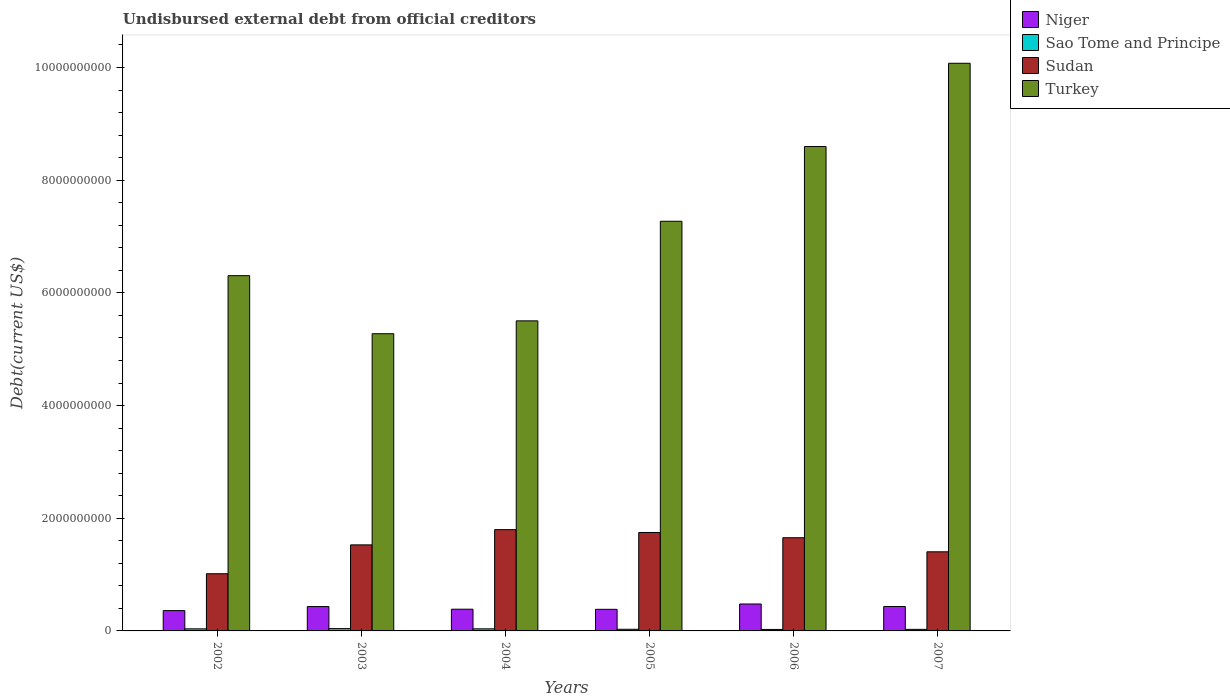How many different coloured bars are there?
Provide a short and direct response. 4. Are the number of bars per tick equal to the number of legend labels?
Give a very brief answer. Yes. Are the number of bars on each tick of the X-axis equal?
Make the answer very short. Yes. How many bars are there on the 3rd tick from the left?
Provide a short and direct response. 4. How many bars are there on the 3rd tick from the right?
Offer a terse response. 4. What is the label of the 1st group of bars from the left?
Make the answer very short. 2002. What is the total debt in Sao Tome and Principe in 2002?
Provide a succinct answer. 3.68e+07. Across all years, what is the maximum total debt in Sudan?
Your answer should be compact. 1.80e+09. Across all years, what is the minimum total debt in Sudan?
Your answer should be very brief. 1.02e+09. In which year was the total debt in Turkey minimum?
Your answer should be very brief. 2003. What is the total total debt in Turkey in the graph?
Provide a succinct answer. 4.30e+1. What is the difference between the total debt in Sao Tome and Principe in 2002 and that in 2005?
Make the answer very short. 7.40e+06. What is the difference between the total debt in Turkey in 2005 and the total debt in Sao Tome and Principe in 2006?
Your answer should be very brief. 7.24e+09. What is the average total debt in Sudan per year?
Provide a short and direct response. 1.52e+09. In the year 2007, what is the difference between the total debt in Turkey and total debt in Sao Tome and Principe?
Your response must be concise. 1.00e+1. In how many years, is the total debt in Niger greater than 2400000000 US$?
Offer a terse response. 0. What is the ratio of the total debt in Niger in 2003 to that in 2005?
Offer a terse response. 1.13. Is the total debt in Sudan in 2003 less than that in 2004?
Ensure brevity in your answer.  Yes. Is the difference between the total debt in Turkey in 2002 and 2004 greater than the difference between the total debt in Sao Tome and Principe in 2002 and 2004?
Your answer should be very brief. Yes. What is the difference between the highest and the second highest total debt in Turkey?
Make the answer very short. 1.48e+09. What is the difference between the highest and the lowest total debt in Turkey?
Offer a terse response. 4.80e+09. Is the sum of the total debt in Niger in 2003 and 2005 greater than the maximum total debt in Sao Tome and Principe across all years?
Provide a short and direct response. Yes. What does the 3rd bar from the left in 2004 represents?
Your answer should be very brief. Sudan. What does the 3rd bar from the right in 2005 represents?
Your answer should be compact. Sao Tome and Principe. Are all the bars in the graph horizontal?
Offer a terse response. No. Does the graph contain grids?
Offer a terse response. No. Where does the legend appear in the graph?
Ensure brevity in your answer.  Top right. How many legend labels are there?
Make the answer very short. 4. What is the title of the graph?
Your response must be concise. Undisbursed external debt from official creditors. Does "Lower middle income" appear as one of the legend labels in the graph?
Offer a terse response. No. What is the label or title of the Y-axis?
Your answer should be compact. Debt(current US$). What is the Debt(current US$) of Niger in 2002?
Provide a short and direct response. 3.61e+08. What is the Debt(current US$) in Sao Tome and Principe in 2002?
Ensure brevity in your answer.  3.68e+07. What is the Debt(current US$) of Sudan in 2002?
Provide a succinct answer. 1.02e+09. What is the Debt(current US$) in Turkey in 2002?
Your response must be concise. 6.31e+09. What is the Debt(current US$) in Niger in 2003?
Your answer should be compact. 4.32e+08. What is the Debt(current US$) in Sao Tome and Principe in 2003?
Offer a very short reply. 4.12e+07. What is the Debt(current US$) in Sudan in 2003?
Give a very brief answer. 1.53e+09. What is the Debt(current US$) in Turkey in 2003?
Your response must be concise. 5.28e+09. What is the Debt(current US$) in Niger in 2004?
Keep it short and to the point. 3.85e+08. What is the Debt(current US$) in Sao Tome and Principe in 2004?
Your response must be concise. 3.71e+07. What is the Debt(current US$) in Sudan in 2004?
Provide a short and direct response. 1.80e+09. What is the Debt(current US$) of Turkey in 2004?
Provide a succinct answer. 5.50e+09. What is the Debt(current US$) in Niger in 2005?
Give a very brief answer. 3.83e+08. What is the Debt(current US$) of Sao Tome and Principe in 2005?
Give a very brief answer. 2.94e+07. What is the Debt(current US$) in Sudan in 2005?
Offer a very short reply. 1.75e+09. What is the Debt(current US$) in Turkey in 2005?
Your answer should be compact. 7.27e+09. What is the Debt(current US$) in Niger in 2006?
Keep it short and to the point. 4.78e+08. What is the Debt(current US$) in Sao Tome and Principe in 2006?
Your answer should be very brief. 2.65e+07. What is the Debt(current US$) of Sudan in 2006?
Your response must be concise. 1.65e+09. What is the Debt(current US$) of Turkey in 2006?
Give a very brief answer. 8.60e+09. What is the Debt(current US$) of Niger in 2007?
Your answer should be very brief. 4.34e+08. What is the Debt(current US$) of Sao Tome and Principe in 2007?
Provide a short and direct response. 2.78e+07. What is the Debt(current US$) of Sudan in 2007?
Give a very brief answer. 1.40e+09. What is the Debt(current US$) in Turkey in 2007?
Ensure brevity in your answer.  1.01e+1. Across all years, what is the maximum Debt(current US$) of Niger?
Offer a terse response. 4.78e+08. Across all years, what is the maximum Debt(current US$) in Sao Tome and Principe?
Your answer should be very brief. 4.12e+07. Across all years, what is the maximum Debt(current US$) in Sudan?
Give a very brief answer. 1.80e+09. Across all years, what is the maximum Debt(current US$) of Turkey?
Make the answer very short. 1.01e+1. Across all years, what is the minimum Debt(current US$) of Niger?
Offer a very short reply. 3.61e+08. Across all years, what is the minimum Debt(current US$) of Sao Tome and Principe?
Make the answer very short. 2.65e+07. Across all years, what is the minimum Debt(current US$) in Sudan?
Offer a very short reply. 1.02e+09. Across all years, what is the minimum Debt(current US$) in Turkey?
Ensure brevity in your answer.  5.28e+09. What is the total Debt(current US$) in Niger in the graph?
Give a very brief answer. 2.47e+09. What is the total Debt(current US$) in Sao Tome and Principe in the graph?
Your answer should be very brief. 1.99e+08. What is the total Debt(current US$) of Sudan in the graph?
Your response must be concise. 9.15e+09. What is the total Debt(current US$) of Turkey in the graph?
Ensure brevity in your answer.  4.30e+1. What is the difference between the Debt(current US$) of Niger in 2002 and that in 2003?
Your response must be concise. -7.17e+07. What is the difference between the Debt(current US$) of Sao Tome and Principe in 2002 and that in 2003?
Ensure brevity in your answer.  -4.41e+06. What is the difference between the Debt(current US$) in Sudan in 2002 and that in 2003?
Ensure brevity in your answer.  -5.12e+08. What is the difference between the Debt(current US$) of Turkey in 2002 and that in 2003?
Your answer should be very brief. 1.03e+09. What is the difference between the Debt(current US$) in Niger in 2002 and that in 2004?
Make the answer very short. -2.46e+07. What is the difference between the Debt(current US$) in Sao Tome and Principe in 2002 and that in 2004?
Provide a short and direct response. -3.19e+05. What is the difference between the Debt(current US$) of Sudan in 2002 and that in 2004?
Make the answer very short. -7.83e+08. What is the difference between the Debt(current US$) in Turkey in 2002 and that in 2004?
Offer a terse response. 8.02e+08. What is the difference between the Debt(current US$) of Niger in 2002 and that in 2005?
Your answer should be compact. -2.27e+07. What is the difference between the Debt(current US$) of Sao Tome and Principe in 2002 and that in 2005?
Your answer should be very brief. 7.40e+06. What is the difference between the Debt(current US$) of Sudan in 2002 and that in 2005?
Offer a terse response. -7.32e+08. What is the difference between the Debt(current US$) of Turkey in 2002 and that in 2005?
Make the answer very short. -9.65e+08. What is the difference between the Debt(current US$) in Niger in 2002 and that in 2006?
Your answer should be compact. -1.17e+08. What is the difference between the Debt(current US$) in Sao Tome and Principe in 2002 and that in 2006?
Offer a very short reply. 1.02e+07. What is the difference between the Debt(current US$) in Sudan in 2002 and that in 2006?
Provide a succinct answer. -6.39e+08. What is the difference between the Debt(current US$) in Turkey in 2002 and that in 2006?
Make the answer very short. -2.29e+09. What is the difference between the Debt(current US$) of Niger in 2002 and that in 2007?
Provide a short and direct response. -7.28e+07. What is the difference between the Debt(current US$) of Sao Tome and Principe in 2002 and that in 2007?
Offer a terse response. 8.94e+06. What is the difference between the Debt(current US$) in Sudan in 2002 and that in 2007?
Offer a terse response. -3.89e+08. What is the difference between the Debt(current US$) in Turkey in 2002 and that in 2007?
Provide a short and direct response. -3.77e+09. What is the difference between the Debt(current US$) of Niger in 2003 and that in 2004?
Your answer should be very brief. 4.70e+07. What is the difference between the Debt(current US$) of Sao Tome and Principe in 2003 and that in 2004?
Ensure brevity in your answer.  4.09e+06. What is the difference between the Debt(current US$) in Sudan in 2003 and that in 2004?
Your response must be concise. -2.71e+08. What is the difference between the Debt(current US$) in Turkey in 2003 and that in 2004?
Make the answer very short. -2.28e+08. What is the difference between the Debt(current US$) of Niger in 2003 and that in 2005?
Offer a very short reply. 4.89e+07. What is the difference between the Debt(current US$) of Sao Tome and Principe in 2003 and that in 2005?
Offer a very short reply. 1.18e+07. What is the difference between the Debt(current US$) in Sudan in 2003 and that in 2005?
Offer a very short reply. -2.20e+08. What is the difference between the Debt(current US$) of Turkey in 2003 and that in 2005?
Make the answer very short. -2.00e+09. What is the difference between the Debt(current US$) of Niger in 2003 and that in 2006?
Give a very brief answer. -4.54e+07. What is the difference between the Debt(current US$) of Sao Tome and Principe in 2003 and that in 2006?
Your response must be concise. 1.46e+07. What is the difference between the Debt(current US$) in Sudan in 2003 and that in 2006?
Offer a terse response. -1.27e+08. What is the difference between the Debt(current US$) of Turkey in 2003 and that in 2006?
Your answer should be very brief. -3.32e+09. What is the difference between the Debt(current US$) in Niger in 2003 and that in 2007?
Give a very brief answer. -1.14e+06. What is the difference between the Debt(current US$) of Sao Tome and Principe in 2003 and that in 2007?
Your answer should be very brief. 1.34e+07. What is the difference between the Debt(current US$) of Sudan in 2003 and that in 2007?
Provide a short and direct response. 1.23e+08. What is the difference between the Debt(current US$) of Turkey in 2003 and that in 2007?
Keep it short and to the point. -4.80e+09. What is the difference between the Debt(current US$) in Niger in 2004 and that in 2005?
Your answer should be compact. 1.90e+06. What is the difference between the Debt(current US$) in Sao Tome and Principe in 2004 and that in 2005?
Your answer should be compact. 7.72e+06. What is the difference between the Debt(current US$) of Sudan in 2004 and that in 2005?
Provide a short and direct response. 5.05e+07. What is the difference between the Debt(current US$) of Turkey in 2004 and that in 2005?
Your response must be concise. -1.77e+09. What is the difference between the Debt(current US$) of Niger in 2004 and that in 2006?
Your answer should be very brief. -9.25e+07. What is the difference between the Debt(current US$) in Sao Tome and Principe in 2004 and that in 2006?
Provide a succinct answer. 1.06e+07. What is the difference between the Debt(current US$) in Sudan in 2004 and that in 2006?
Your answer should be compact. 1.44e+08. What is the difference between the Debt(current US$) of Turkey in 2004 and that in 2006?
Give a very brief answer. -3.09e+09. What is the difference between the Debt(current US$) of Niger in 2004 and that in 2007?
Provide a short and direct response. -4.82e+07. What is the difference between the Debt(current US$) in Sao Tome and Principe in 2004 and that in 2007?
Keep it short and to the point. 9.26e+06. What is the difference between the Debt(current US$) of Sudan in 2004 and that in 2007?
Provide a short and direct response. 3.93e+08. What is the difference between the Debt(current US$) of Turkey in 2004 and that in 2007?
Your response must be concise. -4.57e+09. What is the difference between the Debt(current US$) of Niger in 2005 and that in 2006?
Offer a terse response. -9.44e+07. What is the difference between the Debt(current US$) of Sao Tome and Principe in 2005 and that in 2006?
Offer a terse response. 2.83e+06. What is the difference between the Debt(current US$) in Sudan in 2005 and that in 2006?
Your answer should be compact. 9.31e+07. What is the difference between the Debt(current US$) in Turkey in 2005 and that in 2006?
Offer a very short reply. -1.33e+09. What is the difference between the Debt(current US$) in Niger in 2005 and that in 2007?
Give a very brief answer. -5.01e+07. What is the difference between the Debt(current US$) of Sao Tome and Principe in 2005 and that in 2007?
Provide a short and direct response. 1.54e+06. What is the difference between the Debt(current US$) in Sudan in 2005 and that in 2007?
Make the answer very short. 3.43e+08. What is the difference between the Debt(current US$) in Turkey in 2005 and that in 2007?
Your response must be concise. -2.80e+09. What is the difference between the Debt(current US$) in Niger in 2006 and that in 2007?
Offer a very short reply. 4.43e+07. What is the difference between the Debt(current US$) in Sao Tome and Principe in 2006 and that in 2007?
Keep it short and to the point. -1.29e+06. What is the difference between the Debt(current US$) of Sudan in 2006 and that in 2007?
Give a very brief answer. 2.50e+08. What is the difference between the Debt(current US$) of Turkey in 2006 and that in 2007?
Ensure brevity in your answer.  -1.48e+09. What is the difference between the Debt(current US$) in Niger in 2002 and the Debt(current US$) in Sao Tome and Principe in 2003?
Provide a succinct answer. 3.20e+08. What is the difference between the Debt(current US$) of Niger in 2002 and the Debt(current US$) of Sudan in 2003?
Offer a terse response. -1.17e+09. What is the difference between the Debt(current US$) in Niger in 2002 and the Debt(current US$) in Turkey in 2003?
Your answer should be compact. -4.91e+09. What is the difference between the Debt(current US$) of Sao Tome and Principe in 2002 and the Debt(current US$) of Sudan in 2003?
Keep it short and to the point. -1.49e+09. What is the difference between the Debt(current US$) in Sao Tome and Principe in 2002 and the Debt(current US$) in Turkey in 2003?
Offer a very short reply. -5.24e+09. What is the difference between the Debt(current US$) in Sudan in 2002 and the Debt(current US$) in Turkey in 2003?
Give a very brief answer. -4.26e+09. What is the difference between the Debt(current US$) of Niger in 2002 and the Debt(current US$) of Sao Tome and Principe in 2004?
Make the answer very short. 3.24e+08. What is the difference between the Debt(current US$) of Niger in 2002 and the Debt(current US$) of Sudan in 2004?
Keep it short and to the point. -1.44e+09. What is the difference between the Debt(current US$) of Niger in 2002 and the Debt(current US$) of Turkey in 2004?
Your response must be concise. -5.14e+09. What is the difference between the Debt(current US$) in Sao Tome and Principe in 2002 and the Debt(current US$) in Sudan in 2004?
Offer a terse response. -1.76e+09. What is the difference between the Debt(current US$) in Sao Tome and Principe in 2002 and the Debt(current US$) in Turkey in 2004?
Provide a succinct answer. -5.47e+09. What is the difference between the Debt(current US$) in Sudan in 2002 and the Debt(current US$) in Turkey in 2004?
Offer a very short reply. -4.49e+09. What is the difference between the Debt(current US$) in Niger in 2002 and the Debt(current US$) in Sao Tome and Principe in 2005?
Your answer should be very brief. 3.31e+08. What is the difference between the Debt(current US$) in Niger in 2002 and the Debt(current US$) in Sudan in 2005?
Your response must be concise. -1.39e+09. What is the difference between the Debt(current US$) of Niger in 2002 and the Debt(current US$) of Turkey in 2005?
Your answer should be compact. -6.91e+09. What is the difference between the Debt(current US$) of Sao Tome and Principe in 2002 and the Debt(current US$) of Sudan in 2005?
Provide a succinct answer. -1.71e+09. What is the difference between the Debt(current US$) in Sao Tome and Principe in 2002 and the Debt(current US$) in Turkey in 2005?
Your response must be concise. -7.23e+09. What is the difference between the Debt(current US$) in Sudan in 2002 and the Debt(current US$) in Turkey in 2005?
Make the answer very short. -6.26e+09. What is the difference between the Debt(current US$) in Niger in 2002 and the Debt(current US$) in Sao Tome and Principe in 2006?
Provide a short and direct response. 3.34e+08. What is the difference between the Debt(current US$) in Niger in 2002 and the Debt(current US$) in Sudan in 2006?
Your answer should be very brief. -1.29e+09. What is the difference between the Debt(current US$) in Niger in 2002 and the Debt(current US$) in Turkey in 2006?
Your response must be concise. -8.24e+09. What is the difference between the Debt(current US$) of Sao Tome and Principe in 2002 and the Debt(current US$) of Sudan in 2006?
Keep it short and to the point. -1.62e+09. What is the difference between the Debt(current US$) of Sao Tome and Principe in 2002 and the Debt(current US$) of Turkey in 2006?
Provide a succinct answer. -8.56e+09. What is the difference between the Debt(current US$) of Sudan in 2002 and the Debt(current US$) of Turkey in 2006?
Ensure brevity in your answer.  -7.58e+09. What is the difference between the Debt(current US$) of Niger in 2002 and the Debt(current US$) of Sao Tome and Principe in 2007?
Provide a succinct answer. 3.33e+08. What is the difference between the Debt(current US$) of Niger in 2002 and the Debt(current US$) of Sudan in 2007?
Offer a very short reply. -1.04e+09. What is the difference between the Debt(current US$) of Niger in 2002 and the Debt(current US$) of Turkey in 2007?
Your answer should be compact. -9.71e+09. What is the difference between the Debt(current US$) in Sao Tome and Principe in 2002 and the Debt(current US$) in Sudan in 2007?
Keep it short and to the point. -1.37e+09. What is the difference between the Debt(current US$) of Sao Tome and Principe in 2002 and the Debt(current US$) of Turkey in 2007?
Give a very brief answer. -1.00e+1. What is the difference between the Debt(current US$) of Sudan in 2002 and the Debt(current US$) of Turkey in 2007?
Offer a terse response. -9.06e+09. What is the difference between the Debt(current US$) in Niger in 2003 and the Debt(current US$) in Sao Tome and Principe in 2004?
Your answer should be compact. 3.95e+08. What is the difference between the Debt(current US$) of Niger in 2003 and the Debt(current US$) of Sudan in 2004?
Offer a very short reply. -1.37e+09. What is the difference between the Debt(current US$) of Niger in 2003 and the Debt(current US$) of Turkey in 2004?
Offer a very short reply. -5.07e+09. What is the difference between the Debt(current US$) in Sao Tome and Principe in 2003 and the Debt(current US$) in Sudan in 2004?
Provide a short and direct response. -1.76e+09. What is the difference between the Debt(current US$) of Sao Tome and Principe in 2003 and the Debt(current US$) of Turkey in 2004?
Make the answer very short. -5.46e+09. What is the difference between the Debt(current US$) of Sudan in 2003 and the Debt(current US$) of Turkey in 2004?
Your response must be concise. -3.98e+09. What is the difference between the Debt(current US$) of Niger in 2003 and the Debt(current US$) of Sao Tome and Principe in 2005?
Offer a terse response. 4.03e+08. What is the difference between the Debt(current US$) in Niger in 2003 and the Debt(current US$) in Sudan in 2005?
Your response must be concise. -1.31e+09. What is the difference between the Debt(current US$) of Niger in 2003 and the Debt(current US$) of Turkey in 2005?
Keep it short and to the point. -6.84e+09. What is the difference between the Debt(current US$) of Sao Tome and Principe in 2003 and the Debt(current US$) of Sudan in 2005?
Ensure brevity in your answer.  -1.71e+09. What is the difference between the Debt(current US$) in Sao Tome and Principe in 2003 and the Debt(current US$) in Turkey in 2005?
Offer a terse response. -7.23e+09. What is the difference between the Debt(current US$) in Sudan in 2003 and the Debt(current US$) in Turkey in 2005?
Your answer should be very brief. -5.74e+09. What is the difference between the Debt(current US$) of Niger in 2003 and the Debt(current US$) of Sao Tome and Principe in 2006?
Make the answer very short. 4.06e+08. What is the difference between the Debt(current US$) in Niger in 2003 and the Debt(current US$) in Sudan in 2006?
Give a very brief answer. -1.22e+09. What is the difference between the Debt(current US$) in Niger in 2003 and the Debt(current US$) in Turkey in 2006?
Provide a short and direct response. -8.16e+09. What is the difference between the Debt(current US$) of Sao Tome and Principe in 2003 and the Debt(current US$) of Sudan in 2006?
Offer a terse response. -1.61e+09. What is the difference between the Debt(current US$) in Sao Tome and Principe in 2003 and the Debt(current US$) in Turkey in 2006?
Offer a terse response. -8.56e+09. What is the difference between the Debt(current US$) in Sudan in 2003 and the Debt(current US$) in Turkey in 2006?
Your answer should be compact. -7.07e+09. What is the difference between the Debt(current US$) in Niger in 2003 and the Debt(current US$) in Sao Tome and Principe in 2007?
Offer a very short reply. 4.05e+08. What is the difference between the Debt(current US$) of Niger in 2003 and the Debt(current US$) of Sudan in 2007?
Offer a very short reply. -9.72e+08. What is the difference between the Debt(current US$) of Niger in 2003 and the Debt(current US$) of Turkey in 2007?
Make the answer very short. -9.64e+09. What is the difference between the Debt(current US$) of Sao Tome and Principe in 2003 and the Debt(current US$) of Sudan in 2007?
Provide a succinct answer. -1.36e+09. What is the difference between the Debt(current US$) of Sao Tome and Principe in 2003 and the Debt(current US$) of Turkey in 2007?
Provide a succinct answer. -1.00e+1. What is the difference between the Debt(current US$) in Sudan in 2003 and the Debt(current US$) in Turkey in 2007?
Offer a terse response. -8.55e+09. What is the difference between the Debt(current US$) of Niger in 2004 and the Debt(current US$) of Sao Tome and Principe in 2005?
Make the answer very short. 3.56e+08. What is the difference between the Debt(current US$) of Niger in 2004 and the Debt(current US$) of Sudan in 2005?
Offer a terse response. -1.36e+09. What is the difference between the Debt(current US$) in Niger in 2004 and the Debt(current US$) in Turkey in 2005?
Make the answer very short. -6.89e+09. What is the difference between the Debt(current US$) in Sao Tome and Principe in 2004 and the Debt(current US$) in Sudan in 2005?
Your answer should be compact. -1.71e+09. What is the difference between the Debt(current US$) in Sao Tome and Principe in 2004 and the Debt(current US$) in Turkey in 2005?
Your answer should be very brief. -7.23e+09. What is the difference between the Debt(current US$) in Sudan in 2004 and the Debt(current US$) in Turkey in 2005?
Provide a short and direct response. -5.47e+09. What is the difference between the Debt(current US$) of Niger in 2004 and the Debt(current US$) of Sao Tome and Principe in 2006?
Provide a short and direct response. 3.59e+08. What is the difference between the Debt(current US$) in Niger in 2004 and the Debt(current US$) in Sudan in 2006?
Provide a short and direct response. -1.27e+09. What is the difference between the Debt(current US$) of Niger in 2004 and the Debt(current US$) of Turkey in 2006?
Your response must be concise. -8.21e+09. What is the difference between the Debt(current US$) in Sao Tome and Principe in 2004 and the Debt(current US$) in Sudan in 2006?
Provide a short and direct response. -1.62e+09. What is the difference between the Debt(current US$) in Sao Tome and Principe in 2004 and the Debt(current US$) in Turkey in 2006?
Give a very brief answer. -8.56e+09. What is the difference between the Debt(current US$) in Sudan in 2004 and the Debt(current US$) in Turkey in 2006?
Your answer should be very brief. -6.80e+09. What is the difference between the Debt(current US$) of Niger in 2004 and the Debt(current US$) of Sao Tome and Principe in 2007?
Your response must be concise. 3.58e+08. What is the difference between the Debt(current US$) of Niger in 2004 and the Debt(current US$) of Sudan in 2007?
Your answer should be compact. -1.02e+09. What is the difference between the Debt(current US$) in Niger in 2004 and the Debt(current US$) in Turkey in 2007?
Provide a short and direct response. -9.69e+09. What is the difference between the Debt(current US$) in Sao Tome and Principe in 2004 and the Debt(current US$) in Sudan in 2007?
Offer a very short reply. -1.37e+09. What is the difference between the Debt(current US$) of Sao Tome and Principe in 2004 and the Debt(current US$) of Turkey in 2007?
Ensure brevity in your answer.  -1.00e+1. What is the difference between the Debt(current US$) of Sudan in 2004 and the Debt(current US$) of Turkey in 2007?
Your answer should be compact. -8.28e+09. What is the difference between the Debt(current US$) in Niger in 2005 and the Debt(current US$) in Sao Tome and Principe in 2006?
Your response must be concise. 3.57e+08. What is the difference between the Debt(current US$) in Niger in 2005 and the Debt(current US$) in Sudan in 2006?
Keep it short and to the point. -1.27e+09. What is the difference between the Debt(current US$) of Niger in 2005 and the Debt(current US$) of Turkey in 2006?
Your answer should be compact. -8.21e+09. What is the difference between the Debt(current US$) of Sao Tome and Principe in 2005 and the Debt(current US$) of Sudan in 2006?
Give a very brief answer. -1.62e+09. What is the difference between the Debt(current US$) in Sao Tome and Principe in 2005 and the Debt(current US$) in Turkey in 2006?
Make the answer very short. -8.57e+09. What is the difference between the Debt(current US$) of Sudan in 2005 and the Debt(current US$) of Turkey in 2006?
Make the answer very short. -6.85e+09. What is the difference between the Debt(current US$) of Niger in 2005 and the Debt(current US$) of Sao Tome and Principe in 2007?
Your response must be concise. 3.56e+08. What is the difference between the Debt(current US$) in Niger in 2005 and the Debt(current US$) in Sudan in 2007?
Your answer should be compact. -1.02e+09. What is the difference between the Debt(current US$) of Niger in 2005 and the Debt(current US$) of Turkey in 2007?
Provide a short and direct response. -9.69e+09. What is the difference between the Debt(current US$) of Sao Tome and Principe in 2005 and the Debt(current US$) of Sudan in 2007?
Your answer should be very brief. -1.37e+09. What is the difference between the Debt(current US$) of Sao Tome and Principe in 2005 and the Debt(current US$) of Turkey in 2007?
Provide a short and direct response. -1.00e+1. What is the difference between the Debt(current US$) of Sudan in 2005 and the Debt(current US$) of Turkey in 2007?
Offer a very short reply. -8.33e+09. What is the difference between the Debt(current US$) of Niger in 2006 and the Debt(current US$) of Sao Tome and Principe in 2007?
Keep it short and to the point. 4.50e+08. What is the difference between the Debt(current US$) of Niger in 2006 and the Debt(current US$) of Sudan in 2007?
Your answer should be very brief. -9.26e+08. What is the difference between the Debt(current US$) in Niger in 2006 and the Debt(current US$) in Turkey in 2007?
Provide a short and direct response. -9.60e+09. What is the difference between the Debt(current US$) in Sao Tome and Principe in 2006 and the Debt(current US$) in Sudan in 2007?
Your answer should be compact. -1.38e+09. What is the difference between the Debt(current US$) in Sao Tome and Principe in 2006 and the Debt(current US$) in Turkey in 2007?
Keep it short and to the point. -1.00e+1. What is the difference between the Debt(current US$) of Sudan in 2006 and the Debt(current US$) of Turkey in 2007?
Offer a terse response. -8.42e+09. What is the average Debt(current US$) of Niger per year?
Offer a terse response. 4.12e+08. What is the average Debt(current US$) in Sao Tome and Principe per year?
Give a very brief answer. 3.31e+07. What is the average Debt(current US$) in Sudan per year?
Keep it short and to the point. 1.52e+09. What is the average Debt(current US$) in Turkey per year?
Make the answer very short. 7.17e+09. In the year 2002, what is the difference between the Debt(current US$) in Niger and Debt(current US$) in Sao Tome and Principe?
Ensure brevity in your answer.  3.24e+08. In the year 2002, what is the difference between the Debt(current US$) of Niger and Debt(current US$) of Sudan?
Your answer should be compact. -6.54e+08. In the year 2002, what is the difference between the Debt(current US$) in Niger and Debt(current US$) in Turkey?
Your answer should be very brief. -5.94e+09. In the year 2002, what is the difference between the Debt(current US$) in Sao Tome and Principe and Debt(current US$) in Sudan?
Offer a terse response. -9.78e+08. In the year 2002, what is the difference between the Debt(current US$) of Sao Tome and Principe and Debt(current US$) of Turkey?
Make the answer very short. -6.27e+09. In the year 2002, what is the difference between the Debt(current US$) in Sudan and Debt(current US$) in Turkey?
Your response must be concise. -5.29e+09. In the year 2003, what is the difference between the Debt(current US$) of Niger and Debt(current US$) of Sao Tome and Principe?
Offer a terse response. 3.91e+08. In the year 2003, what is the difference between the Debt(current US$) in Niger and Debt(current US$) in Sudan?
Make the answer very short. -1.09e+09. In the year 2003, what is the difference between the Debt(current US$) in Niger and Debt(current US$) in Turkey?
Offer a very short reply. -4.84e+09. In the year 2003, what is the difference between the Debt(current US$) in Sao Tome and Principe and Debt(current US$) in Sudan?
Your answer should be very brief. -1.49e+09. In the year 2003, what is the difference between the Debt(current US$) in Sao Tome and Principe and Debt(current US$) in Turkey?
Make the answer very short. -5.23e+09. In the year 2003, what is the difference between the Debt(current US$) of Sudan and Debt(current US$) of Turkey?
Your answer should be compact. -3.75e+09. In the year 2004, what is the difference between the Debt(current US$) of Niger and Debt(current US$) of Sao Tome and Principe?
Keep it short and to the point. 3.48e+08. In the year 2004, what is the difference between the Debt(current US$) of Niger and Debt(current US$) of Sudan?
Keep it short and to the point. -1.41e+09. In the year 2004, what is the difference between the Debt(current US$) in Niger and Debt(current US$) in Turkey?
Offer a very short reply. -5.12e+09. In the year 2004, what is the difference between the Debt(current US$) in Sao Tome and Principe and Debt(current US$) in Sudan?
Offer a terse response. -1.76e+09. In the year 2004, what is the difference between the Debt(current US$) in Sao Tome and Principe and Debt(current US$) in Turkey?
Provide a succinct answer. -5.47e+09. In the year 2004, what is the difference between the Debt(current US$) of Sudan and Debt(current US$) of Turkey?
Ensure brevity in your answer.  -3.71e+09. In the year 2005, what is the difference between the Debt(current US$) in Niger and Debt(current US$) in Sao Tome and Principe?
Provide a succinct answer. 3.54e+08. In the year 2005, what is the difference between the Debt(current US$) in Niger and Debt(current US$) in Sudan?
Provide a succinct answer. -1.36e+09. In the year 2005, what is the difference between the Debt(current US$) of Niger and Debt(current US$) of Turkey?
Your response must be concise. -6.89e+09. In the year 2005, what is the difference between the Debt(current US$) in Sao Tome and Principe and Debt(current US$) in Sudan?
Give a very brief answer. -1.72e+09. In the year 2005, what is the difference between the Debt(current US$) in Sao Tome and Principe and Debt(current US$) in Turkey?
Your answer should be compact. -7.24e+09. In the year 2005, what is the difference between the Debt(current US$) in Sudan and Debt(current US$) in Turkey?
Offer a very short reply. -5.52e+09. In the year 2006, what is the difference between the Debt(current US$) in Niger and Debt(current US$) in Sao Tome and Principe?
Your answer should be very brief. 4.51e+08. In the year 2006, what is the difference between the Debt(current US$) of Niger and Debt(current US$) of Sudan?
Your answer should be very brief. -1.18e+09. In the year 2006, what is the difference between the Debt(current US$) in Niger and Debt(current US$) in Turkey?
Keep it short and to the point. -8.12e+09. In the year 2006, what is the difference between the Debt(current US$) of Sao Tome and Principe and Debt(current US$) of Sudan?
Keep it short and to the point. -1.63e+09. In the year 2006, what is the difference between the Debt(current US$) in Sao Tome and Principe and Debt(current US$) in Turkey?
Provide a succinct answer. -8.57e+09. In the year 2006, what is the difference between the Debt(current US$) in Sudan and Debt(current US$) in Turkey?
Keep it short and to the point. -6.94e+09. In the year 2007, what is the difference between the Debt(current US$) in Niger and Debt(current US$) in Sao Tome and Principe?
Give a very brief answer. 4.06e+08. In the year 2007, what is the difference between the Debt(current US$) of Niger and Debt(current US$) of Sudan?
Your answer should be compact. -9.71e+08. In the year 2007, what is the difference between the Debt(current US$) of Niger and Debt(current US$) of Turkey?
Offer a very short reply. -9.64e+09. In the year 2007, what is the difference between the Debt(current US$) of Sao Tome and Principe and Debt(current US$) of Sudan?
Your answer should be very brief. -1.38e+09. In the year 2007, what is the difference between the Debt(current US$) of Sao Tome and Principe and Debt(current US$) of Turkey?
Provide a succinct answer. -1.00e+1. In the year 2007, what is the difference between the Debt(current US$) of Sudan and Debt(current US$) of Turkey?
Offer a very short reply. -8.67e+09. What is the ratio of the Debt(current US$) in Niger in 2002 to that in 2003?
Your answer should be very brief. 0.83. What is the ratio of the Debt(current US$) of Sao Tome and Principe in 2002 to that in 2003?
Your answer should be very brief. 0.89. What is the ratio of the Debt(current US$) in Sudan in 2002 to that in 2003?
Offer a very short reply. 0.66. What is the ratio of the Debt(current US$) of Turkey in 2002 to that in 2003?
Provide a succinct answer. 1.2. What is the ratio of the Debt(current US$) in Niger in 2002 to that in 2004?
Provide a succinct answer. 0.94. What is the ratio of the Debt(current US$) of Sao Tome and Principe in 2002 to that in 2004?
Your answer should be compact. 0.99. What is the ratio of the Debt(current US$) of Sudan in 2002 to that in 2004?
Offer a very short reply. 0.56. What is the ratio of the Debt(current US$) of Turkey in 2002 to that in 2004?
Provide a short and direct response. 1.15. What is the ratio of the Debt(current US$) in Niger in 2002 to that in 2005?
Make the answer very short. 0.94. What is the ratio of the Debt(current US$) in Sao Tome and Principe in 2002 to that in 2005?
Give a very brief answer. 1.25. What is the ratio of the Debt(current US$) in Sudan in 2002 to that in 2005?
Ensure brevity in your answer.  0.58. What is the ratio of the Debt(current US$) in Turkey in 2002 to that in 2005?
Offer a terse response. 0.87. What is the ratio of the Debt(current US$) of Niger in 2002 to that in 2006?
Offer a terse response. 0.75. What is the ratio of the Debt(current US$) in Sao Tome and Principe in 2002 to that in 2006?
Keep it short and to the point. 1.39. What is the ratio of the Debt(current US$) in Sudan in 2002 to that in 2006?
Keep it short and to the point. 0.61. What is the ratio of the Debt(current US$) in Turkey in 2002 to that in 2006?
Give a very brief answer. 0.73. What is the ratio of the Debt(current US$) in Niger in 2002 to that in 2007?
Make the answer very short. 0.83. What is the ratio of the Debt(current US$) in Sao Tome and Principe in 2002 to that in 2007?
Your answer should be compact. 1.32. What is the ratio of the Debt(current US$) in Sudan in 2002 to that in 2007?
Make the answer very short. 0.72. What is the ratio of the Debt(current US$) in Turkey in 2002 to that in 2007?
Ensure brevity in your answer.  0.63. What is the ratio of the Debt(current US$) in Niger in 2003 to that in 2004?
Your answer should be very brief. 1.12. What is the ratio of the Debt(current US$) in Sao Tome and Principe in 2003 to that in 2004?
Provide a succinct answer. 1.11. What is the ratio of the Debt(current US$) in Sudan in 2003 to that in 2004?
Keep it short and to the point. 0.85. What is the ratio of the Debt(current US$) of Turkey in 2003 to that in 2004?
Ensure brevity in your answer.  0.96. What is the ratio of the Debt(current US$) of Niger in 2003 to that in 2005?
Provide a short and direct response. 1.13. What is the ratio of the Debt(current US$) in Sao Tome and Principe in 2003 to that in 2005?
Offer a terse response. 1.4. What is the ratio of the Debt(current US$) of Sudan in 2003 to that in 2005?
Keep it short and to the point. 0.87. What is the ratio of the Debt(current US$) in Turkey in 2003 to that in 2005?
Your response must be concise. 0.73. What is the ratio of the Debt(current US$) in Niger in 2003 to that in 2006?
Provide a short and direct response. 0.9. What is the ratio of the Debt(current US$) of Sao Tome and Principe in 2003 to that in 2006?
Offer a very short reply. 1.55. What is the ratio of the Debt(current US$) in Sudan in 2003 to that in 2006?
Ensure brevity in your answer.  0.92. What is the ratio of the Debt(current US$) of Turkey in 2003 to that in 2006?
Offer a terse response. 0.61. What is the ratio of the Debt(current US$) in Sao Tome and Principe in 2003 to that in 2007?
Make the answer very short. 1.48. What is the ratio of the Debt(current US$) of Sudan in 2003 to that in 2007?
Keep it short and to the point. 1.09. What is the ratio of the Debt(current US$) in Turkey in 2003 to that in 2007?
Offer a very short reply. 0.52. What is the ratio of the Debt(current US$) in Niger in 2004 to that in 2005?
Give a very brief answer. 1. What is the ratio of the Debt(current US$) in Sao Tome and Principe in 2004 to that in 2005?
Provide a succinct answer. 1.26. What is the ratio of the Debt(current US$) in Sudan in 2004 to that in 2005?
Make the answer very short. 1.03. What is the ratio of the Debt(current US$) in Turkey in 2004 to that in 2005?
Your response must be concise. 0.76. What is the ratio of the Debt(current US$) of Niger in 2004 to that in 2006?
Give a very brief answer. 0.81. What is the ratio of the Debt(current US$) in Sao Tome and Principe in 2004 to that in 2006?
Your answer should be compact. 1.4. What is the ratio of the Debt(current US$) in Sudan in 2004 to that in 2006?
Keep it short and to the point. 1.09. What is the ratio of the Debt(current US$) in Turkey in 2004 to that in 2006?
Make the answer very short. 0.64. What is the ratio of the Debt(current US$) of Sao Tome and Principe in 2004 to that in 2007?
Make the answer very short. 1.33. What is the ratio of the Debt(current US$) of Sudan in 2004 to that in 2007?
Your response must be concise. 1.28. What is the ratio of the Debt(current US$) in Turkey in 2004 to that in 2007?
Offer a very short reply. 0.55. What is the ratio of the Debt(current US$) of Niger in 2005 to that in 2006?
Provide a short and direct response. 0.8. What is the ratio of the Debt(current US$) of Sao Tome and Principe in 2005 to that in 2006?
Offer a very short reply. 1.11. What is the ratio of the Debt(current US$) in Sudan in 2005 to that in 2006?
Offer a terse response. 1.06. What is the ratio of the Debt(current US$) of Turkey in 2005 to that in 2006?
Ensure brevity in your answer.  0.85. What is the ratio of the Debt(current US$) of Niger in 2005 to that in 2007?
Make the answer very short. 0.88. What is the ratio of the Debt(current US$) of Sao Tome and Principe in 2005 to that in 2007?
Your answer should be very brief. 1.06. What is the ratio of the Debt(current US$) in Sudan in 2005 to that in 2007?
Give a very brief answer. 1.24. What is the ratio of the Debt(current US$) of Turkey in 2005 to that in 2007?
Ensure brevity in your answer.  0.72. What is the ratio of the Debt(current US$) of Niger in 2006 to that in 2007?
Your answer should be very brief. 1.1. What is the ratio of the Debt(current US$) of Sao Tome and Principe in 2006 to that in 2007?
Provide a succinct answer. 0.95. What is the ratio of the Debt(current US$) in Sudan in 2006 to that in 2007?
Keep it short and to the point. 1.18. What is the ratio of the Debt(current US$) in Turkey in 2006 to that in 2007?
Ensure brevity in your answer.  0.85. What is the difference between the highest and the second highest Debt(current US$) of Niger?
Offer a very short reply. 4.43e+07. What is the difference between the highest and the second highest Debt(current US$) of Sao Tome and Principe?
Make the answer very short. 4.09e+06. What is the difference between the highest and the second highest Debt(current US$) in Sudan?
Your answer should be compact. 5.05e+07. What is the difference between the highest and the second highest Debt(current US$) in Turkey?
Ensure brevity in your answer.  1.48e+09. What is the difference between the highest and the lowest Debt(current US$) in Niger?
Your answer should be very brief. 1.17e+08. What is the difference between the highest and the lowest Debt(current US$) of Sao Tome and Principe?
Offer a very short reply. 1.46e+07. What is the difference between the highest and the lowest Debt(current US$) of Sudan?
Give a very brief answer. 7.83e+08. What is the difference between the highest and the lowest Debt(current US$) in Turkey?
Give a very brief answer. 4.80e+09. 